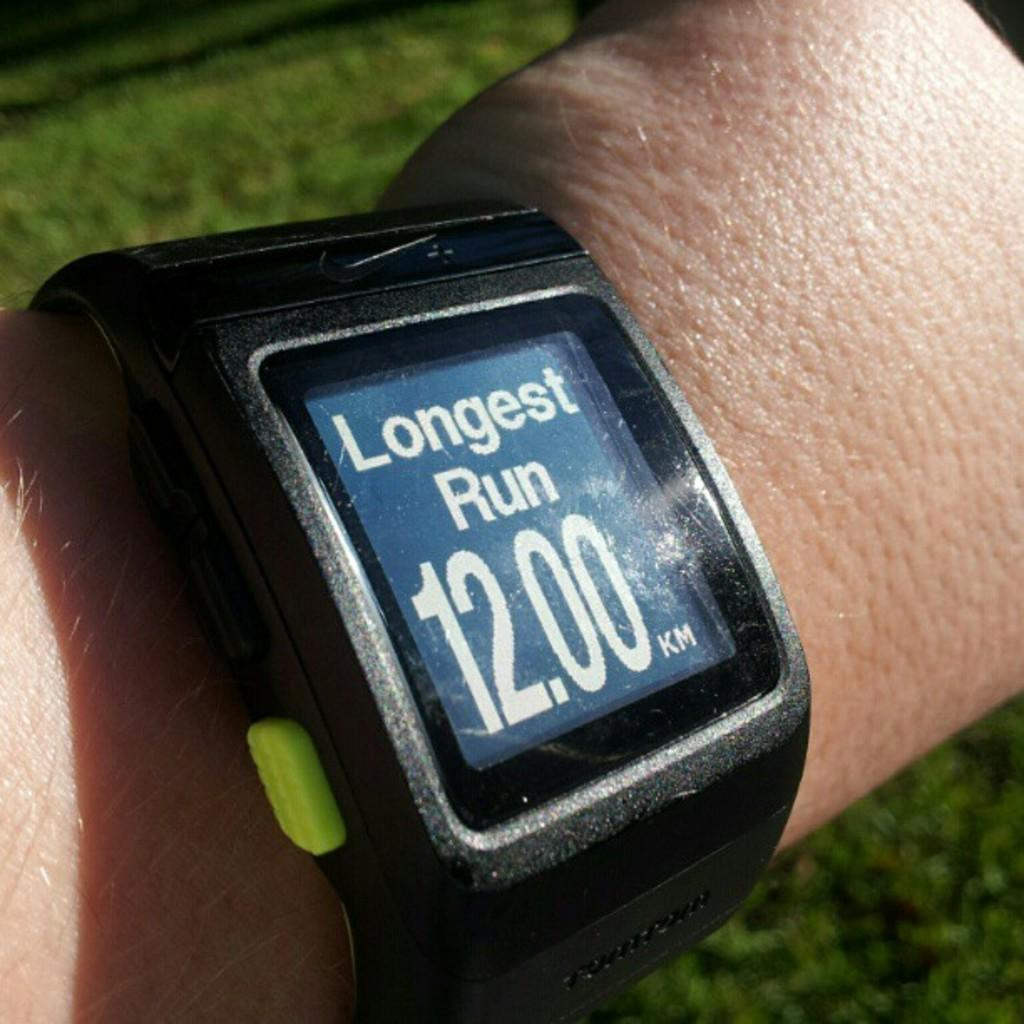<image>
Present a compact description of the photo's key features. A hand wearing a watch that reads longest run twelve kilometers. 